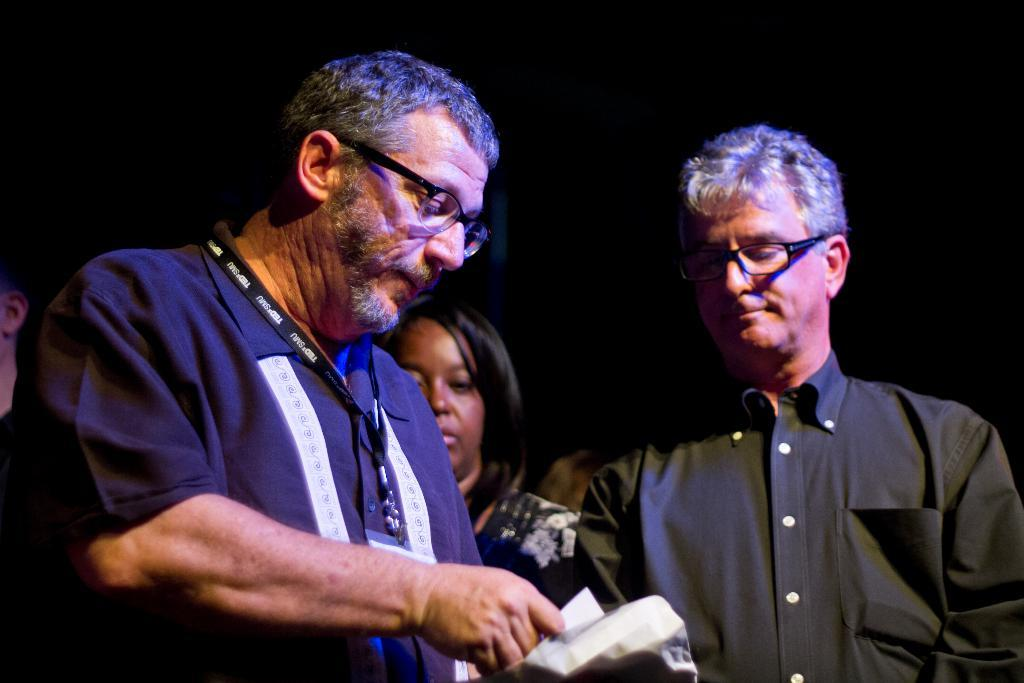Who is the main subject on the left side of the image? There is a man standing on the left side of the image. What is the man holding in his hand? The man is holding a paper in his hand. Who is standing next to the man on the left side? There is a lady standing next to the man. Who is standing next to the lady? There is another man standing next to the lady. What type of bed is visible in the image? There is no bed present in the image. How does the mass of the man on the left side affect the heat distribution in the image? There is no information about mass or heat distribution in the image, as it only features people standing and holding a paper. 